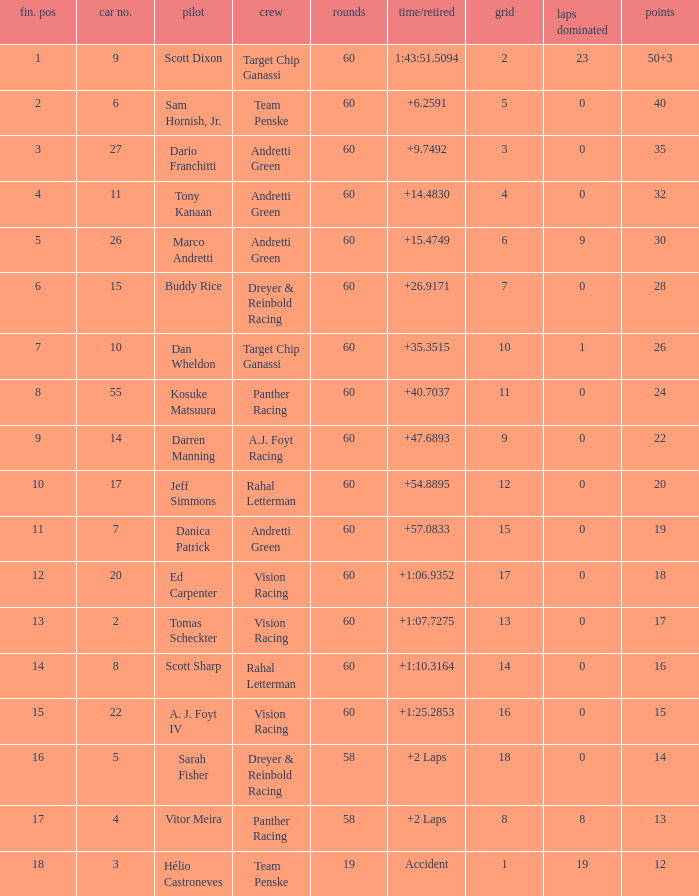Name the laps for 18 pointss 60.0. 